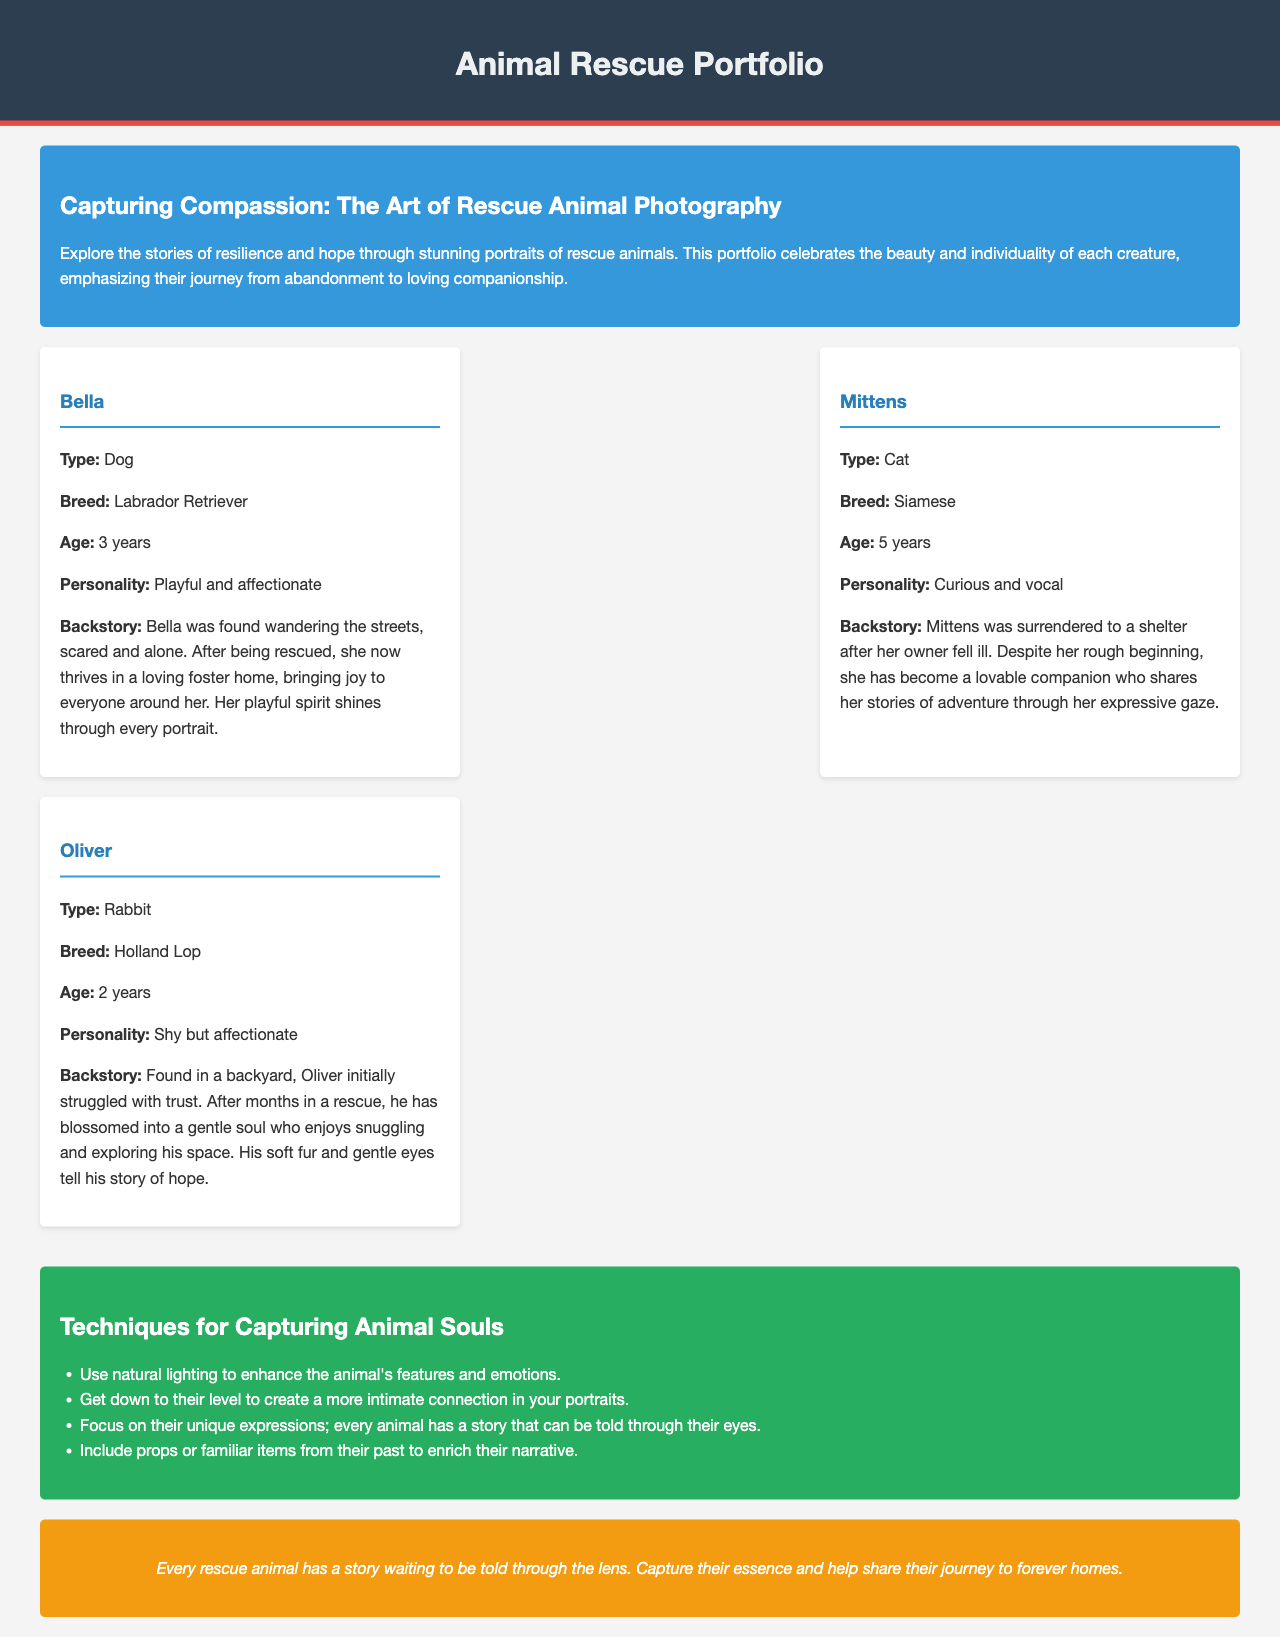What is the title of the document? The title is prominently displayed in the header section of the document.
Answer: Animal Rescue Portfolio Who is the first animal featured in the portfolio? The first animal's profile is listed in the animal profiles section of the document.
Answer: Bella What type of animal is Oliver? The type of animal is specified in the individual animal profiles within the document.
Answer: Rabbit How many years old is Mittens? Mittens' age is stated in her individual profile within the document.
Answer: 5 years What personality trait is associated with Bella? Bella's personality trait is mentioned in her profile.
Answer: Playful and affectionate What color is the background of the tips section? The background color of the tips section is described in the style portion within the code.
Answer: Green How many techniques are listed for capturing animal souls? The number of techniques can be counted from the bulleted list in the tips section.
Answer: Four What type of breed is Mittens? Mittens' breed is directly provided in her profile in the document.
Answer: Siamese What emotion should be highlighted in animal portraits according to the tips? The tips section emphasizes a specific aspect that should be captured during the photography process.
Answer: Emotions 